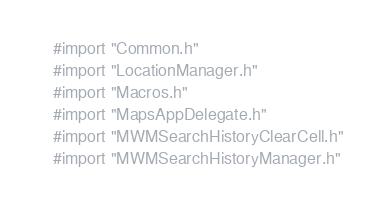Convert code to text. <code><loc_0><loc_0><loc_500><loc_500><_ObjectiveC_>#import "Common.h"
#import "LocationManager.h"
#import "Macros.h"
#import "MapsAppDelegate.h"
#import "MWMSearchHistoryClearCell.h"
#import "MWMSearchHistoryManager.h"</code> 